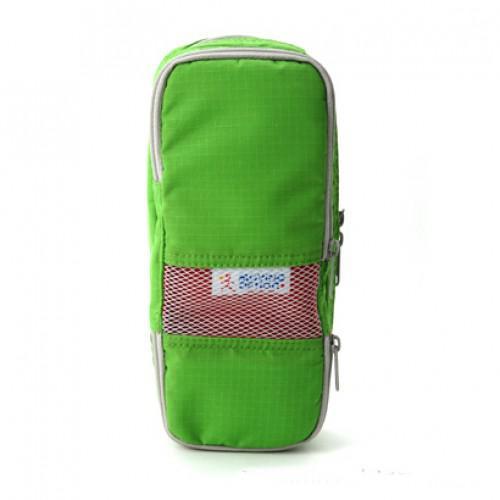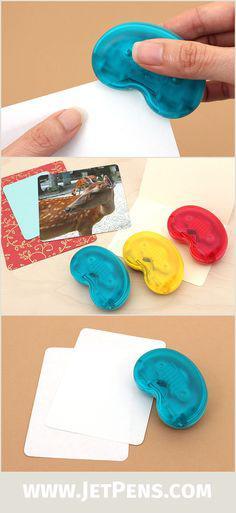The first image is the image on the left, the second image is the image on the right. Given the left and right images, does the statement "there is a mesh pocket on the front of a pencil case" hold true? Answer yes or no. Yes. The first image is the image on the left, the second image is the image on the right. Analyze the images presented: Is the assertion "Two light blue pencil bags are unzipped and showing the inside." valid? Answer yes or no. No. 